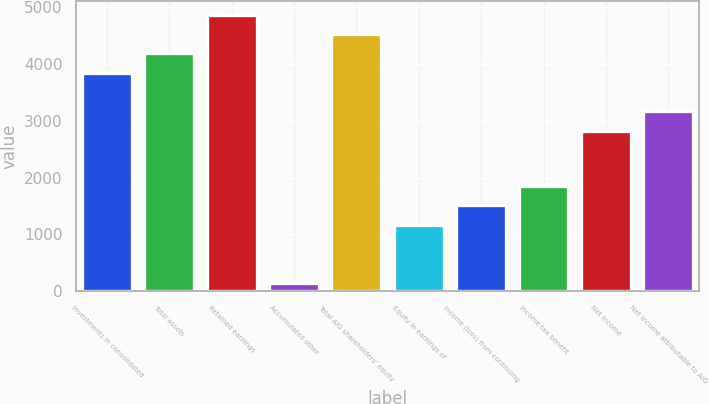Convert chart. <chart><loc_0><loc_0><loc_500><loc_500><bar_chart><fcel>Investments in consolidated<fcel>Total assets<fcel>Retained earnings<fcel>Accumulated other<fcel>Total AIG shareholders' equity<fcel>Equity in earnings of<fcel>Income (loss) from continuing<fcel>Income tax benefit<fcel>Net income<fcel>Net income attributable to AIG<nl><fcel>3847.9<fcel>4189.2<fcel>4871.8<fcel>145<fcel>4530.5<fcel>1168.9<fcel>1510.2<fcel>1851.5<fcel>2824<fcel>3165.3<nl></chart> 